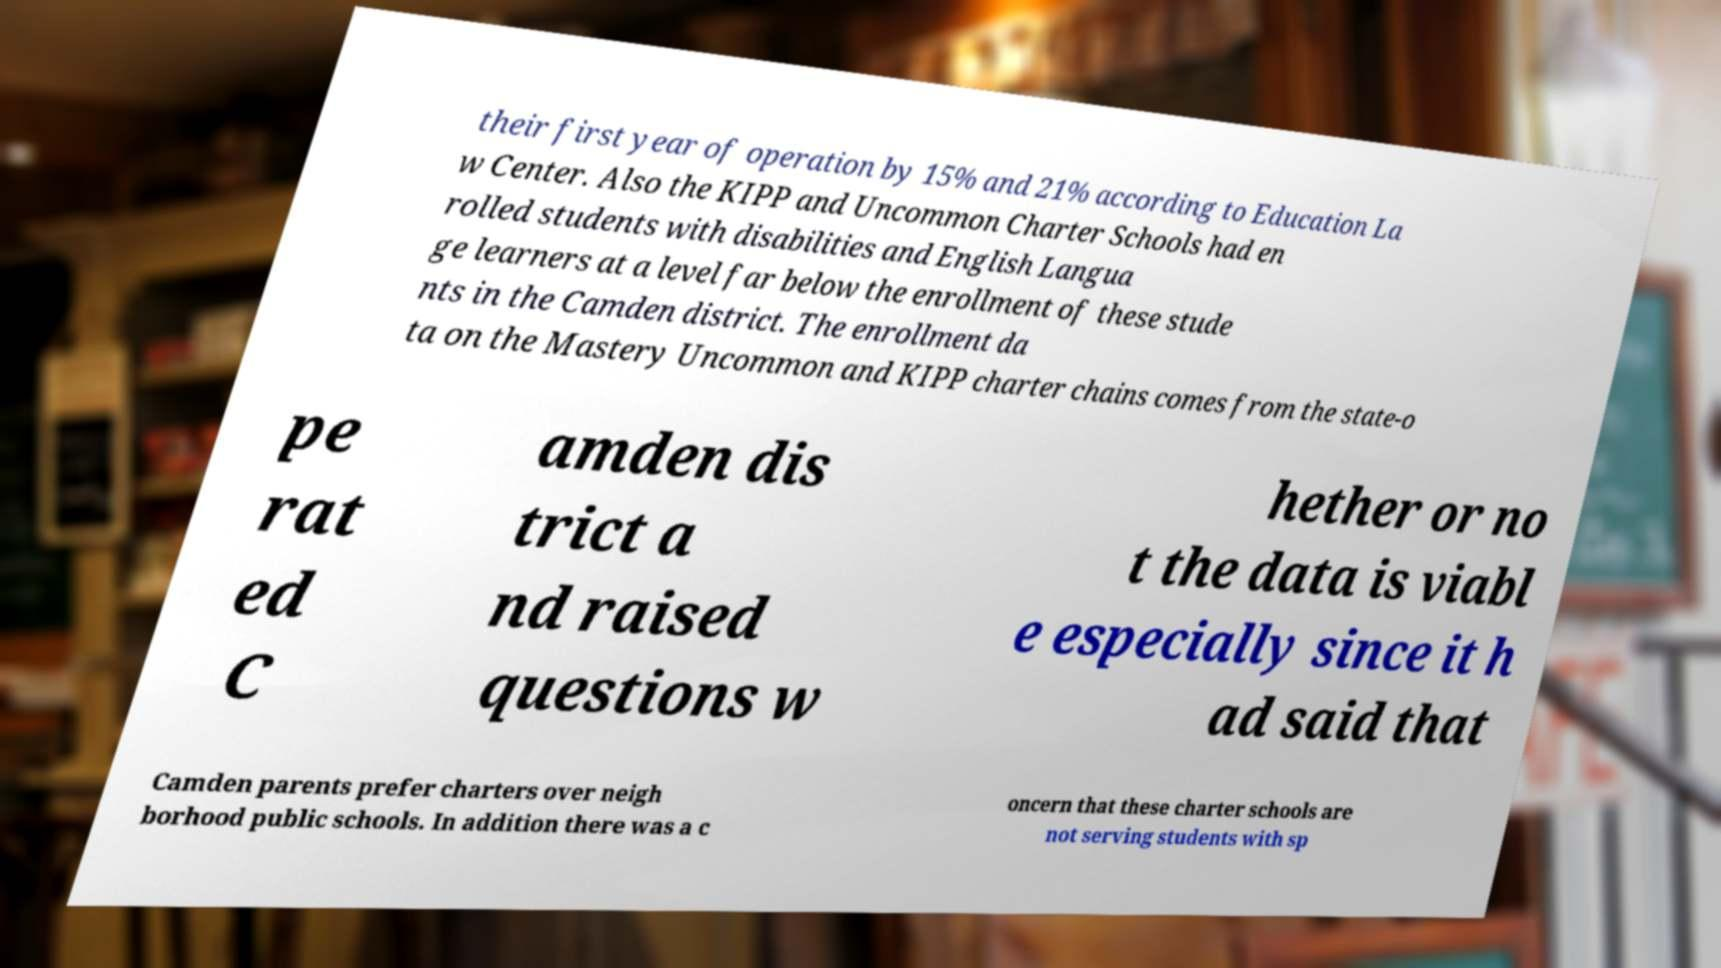Could you extract and type out the text from this image? their first year of operation by 15% and 21% according to Education La w Center. Also the KIPP and Uncommon Charter Schools had en rolled students with disabilities and English Langua ge learners at a level far below the enrollment of these stude nts in the Camden district. The enrollment da ta on the Mastery Uncommon and KIPP charter chains comes from the state-o pe rat ed C amden dis trict a nd raised questions w hether or no t the data is viabl e especially since it h ad said that Camden parents prefer charters over neigh borhood public schools. In addition there was a c oncern that these charter schools are not serving students with sp 